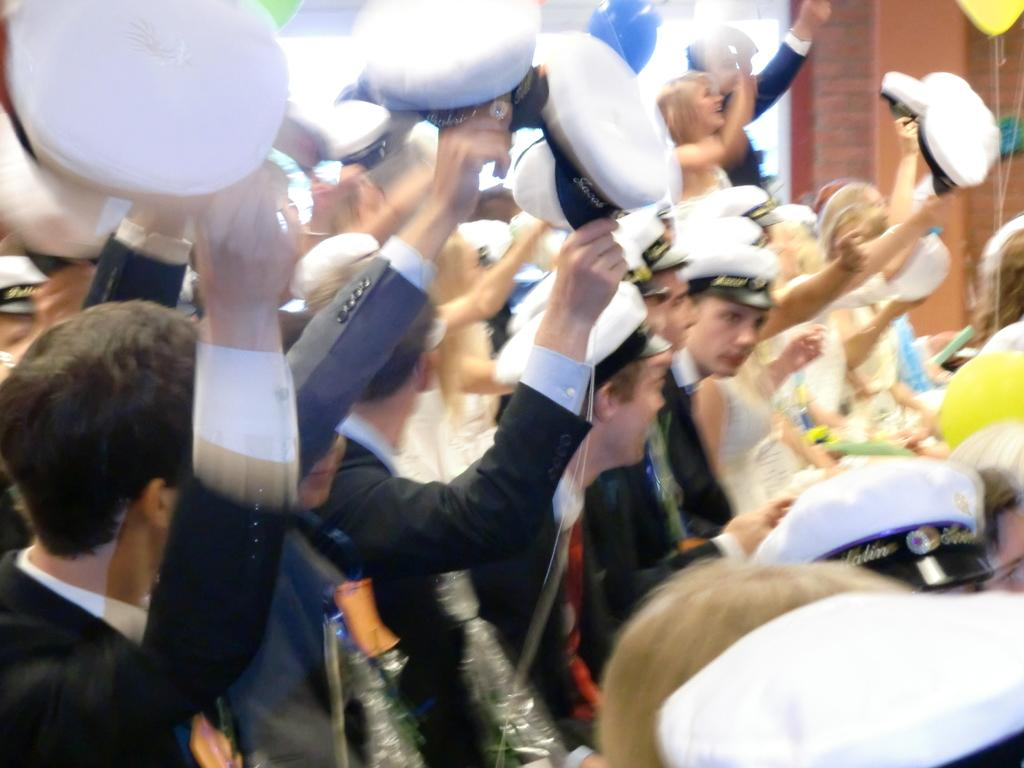What is the main subject of the image? The main subject of the image is a group of people. What accessories are visible on the people in the image? There are hats visible in the image. Where is the balloon located in the image? The balloon is in the top right corner of the image. What type of plants can be seen growing in the image? There are no plants visible in the image. Can you tell me how many quivers are present in the image? There is no mention of quivers in the image, so it cannot be determined if any are present. 